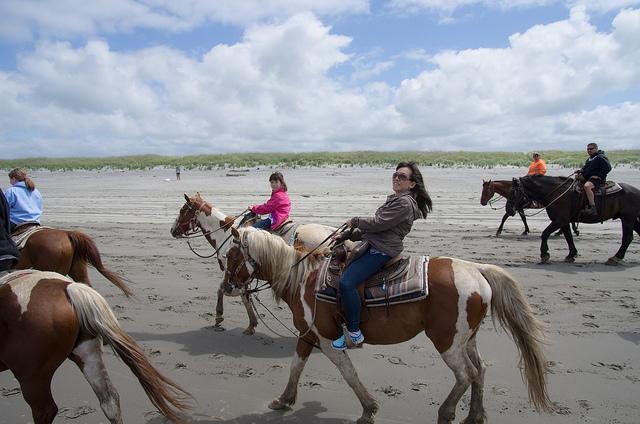How many people are looking towards the photographer?
Short answer required. 4. Is the person riding the horse a grown up?
Quick response, please. Yes. How many dark brown horses are in the photo?
Quick response, please. 2. What are the people riding?
Quick response, please. Horses. 